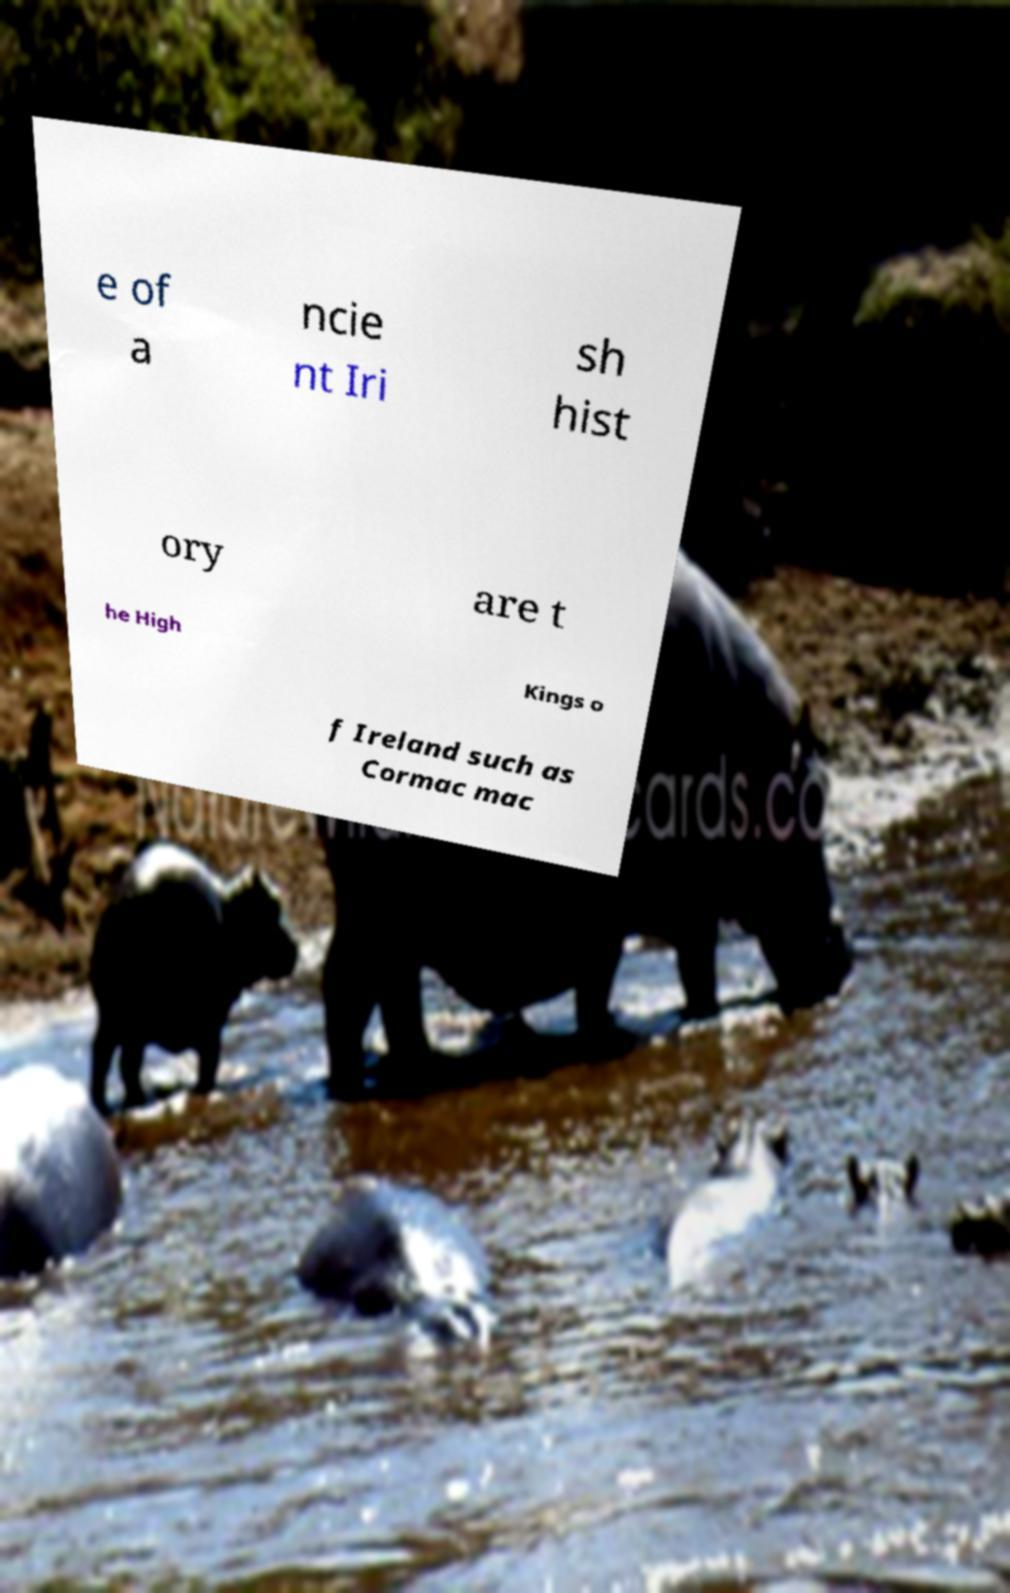For documentation purposes, I need the text within this image transcribed. Could you provide that? e of a ncie nt Iri sh hist ory are t he High Kings o f Ireland such as Cormac mac 